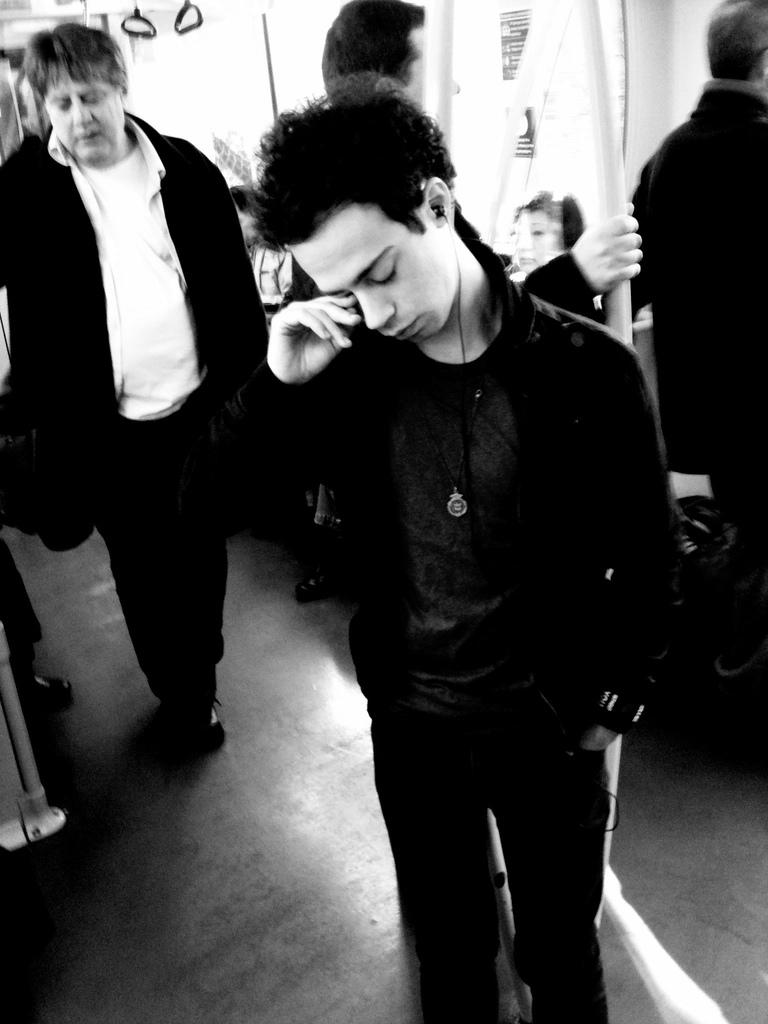What is the main subject of the image? The main subject of the image is a group of persons. Where are the persons located in the image? The persons are standing or sitting in a bus. What is the color scheme of the image? The image is in black and white. What type of print can be seen on the persons' clothing in the image? There is no information about the print on the persons' clothing in the image, as it is in black and white. What action are the persons performing in the image? The provided facts do not mention any specific actions being performed by the persons in the image. 